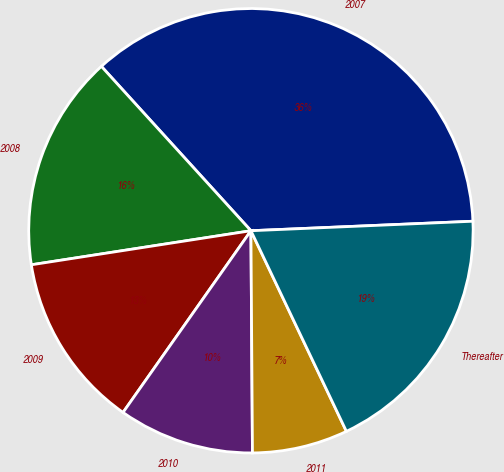<chart> <loc_0><loc_0><loc_500><loc_500><pie_chart><fcel>2007<fcel>2008<fcel>2009<fcel>2010<fcel>2011<fcel>Thereafter<nl><fcel>36.07%<fcel>15.7%<fcel>12.79%<fcel>9.87%<fcel>6.96%<fcel>18.61%<nl></chart> 